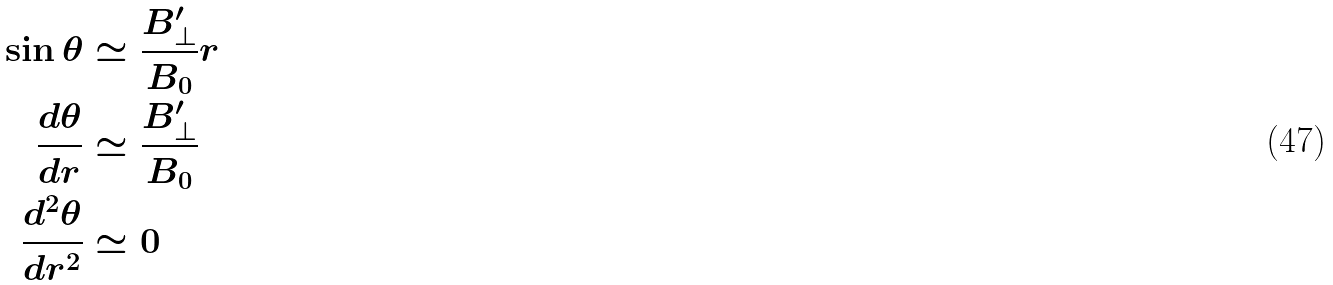<formula> <loc_0><loc_0><loc_500><loc_500>\sin \theta & \simeq \frac { B _ { \bot } ^ { \prime } } { B _ { 0 } } r \\ \frac { d \theta } { d r } & \simeq \frac { B _ { \bot } ^ { \prime } } { B _ { 0 } } \\ \frac { d ^ { 2 } \theta } { d r ^ { 2 } } & \simeq 0</formula> 